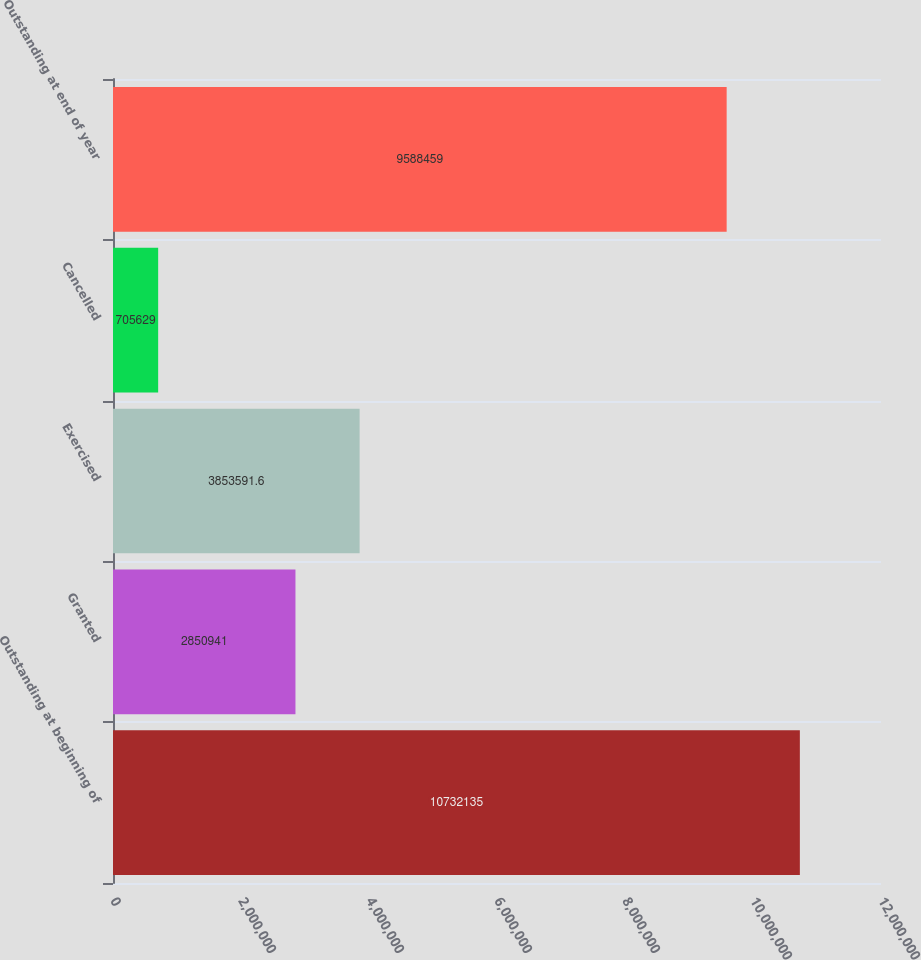Convert chart. <chart><loc_0><loc_0><loc_500><loc_500><bar_chart><fcel>Outstanding at beginning of<fcel>Granted<fcel>Exercised<fcel>Cancelled<fcel>Outstanding at end of year<nl><fcel>1.07321e+07<fcel>2.85094e+06<fcel>3.85359e+06<fcel>705629<fcel>9.58846e+06<nl></chart> 